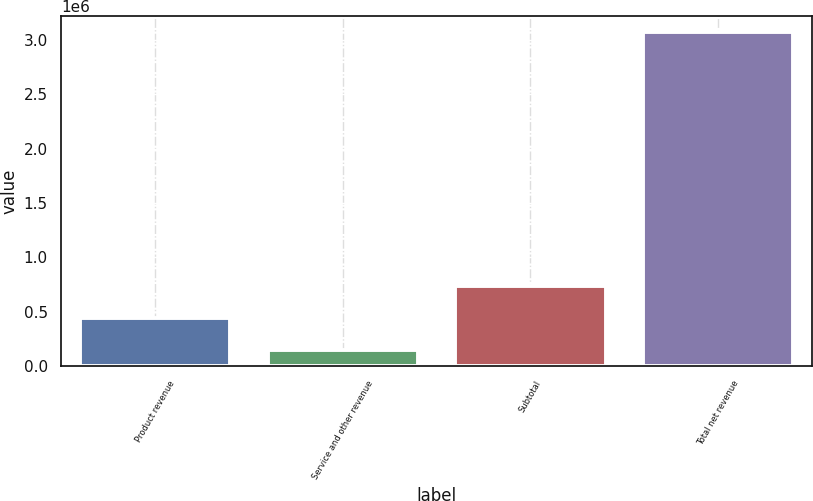Convert chart. <chart><loc_0><loc_0><loc_500><loc_500><bar_chart><fcel>Product revenue<fcel>Service and other revenue<fcel>Subtotal<fcel>Total net revenue<nl><fcel>445787<fcel>146319<fcel>738252<fcel>3.07097e+06<nl></chart> 